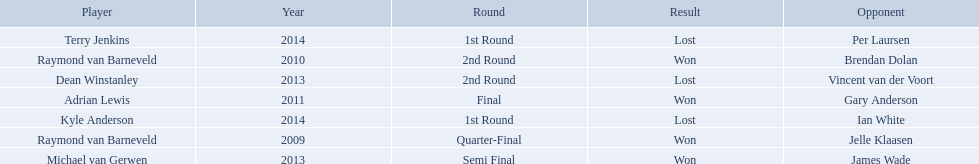What players competed in the pdc world darts championship? Raymond van Barneveld, Raymond van Barneveld, Adrian Lewis, Dean Winstanley, Michael van Gerwen, Terry Jenkins, Kyle Anderson. Of these players, who lost? Dean Winstanley, Terry Jenkins, Kyle Anderson. Which of these players lost in 2014? Terry Jenkins, Kyle Anderson. What are the players other than kyle anderson? Terry Jenkins. 